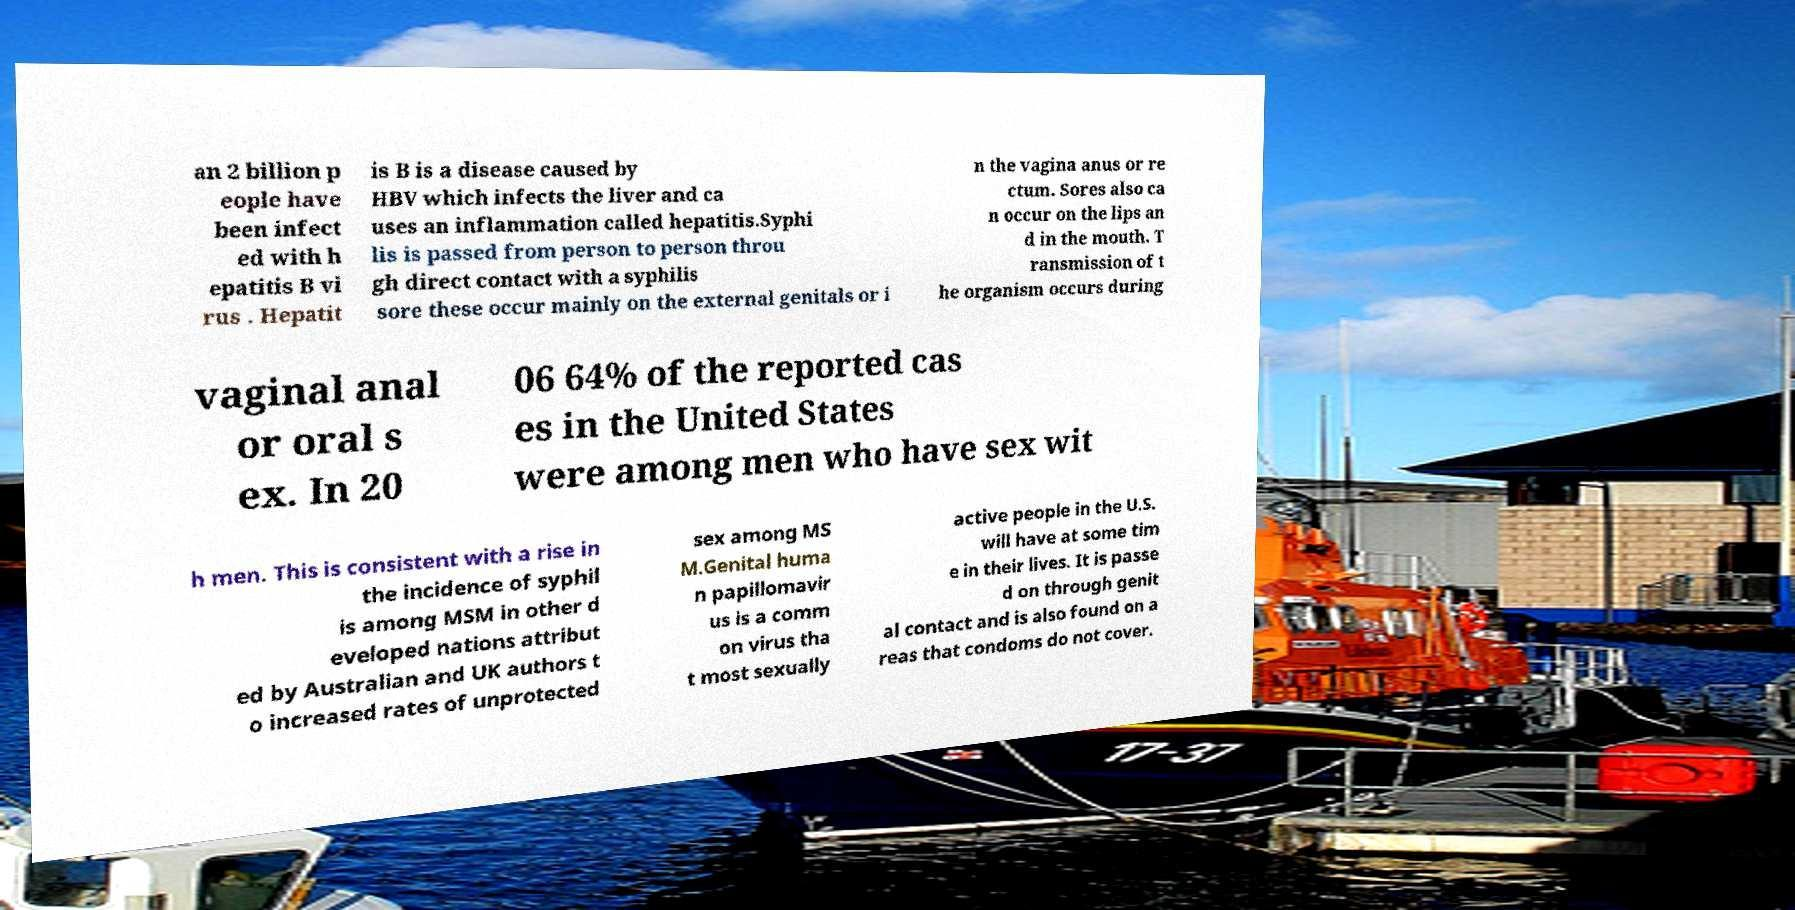There's text embedded in this image that I need extracted. Can you transcribe it verbatim? an 2 billion p eople have been infect ed with h epatitis B vi rus . Hepatit is B is a disease caused by HBV which infects the liver and ca uses an inflammation called hepatitis.Syphi lis is passed from person to person throu gh direct contact with a syphilis sore these occur mainly on the external genitals or i n the vagina anus or re ctum. Sores also ca n occur on the lips an d in the mouth. T ransmission of t he organism occurs during vaginal anal or oral s ex. In 20 06 64% of the reported cas es in the United States were among men who have sex wit h men. This is consistent with a rise in the incidence of syphil is among MSM in other d eveloped nations attribut ed by Australian and UK authors t o increased rates of unprotected sex among MS M.Genital huma n papillomavir us is a comm on virus tha t most sexually active people in the U.S. will have at some tim e in their lives. It is passe d on through genit al contact and is also found on a reas that condoms do not cover. 